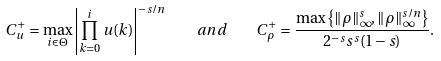<formula> <loc_0><loc_0><loc_500><loc_500>C _ { u } ^ { + } = \max _ { i \in \Theta } \left | \prod _ { k = 0 } ^ { i } u ( k ) \right | ^ { - s / n } \quad a n d \quad C _ { \rho } ^ { + } = \frac { \max \left \{ \| \rho \| _ { \infty } ^ { s } , \| \rho \| _ { \infty } ^ { s / n } \right \} } { 2 ^ { - s } s ^ { s } ( 1 - s ) } .</formula> 